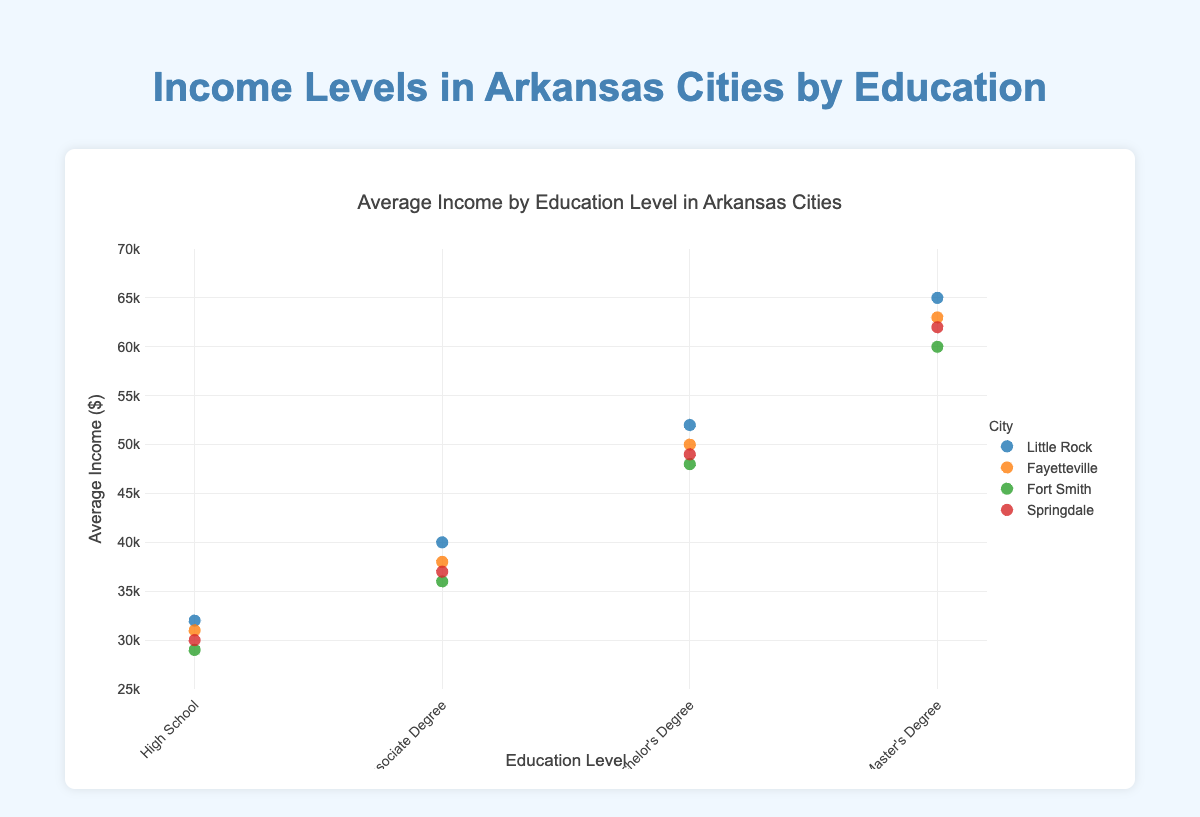what is the title of the chart? The title of the chart is found at the top center of the plot and helps identify the main topic or purpose of the visualization. In this case, it reads "Average Income by Education Level in Arkansas Cities."
Answer: Average Income by Education Level in Arkansas Cities What is the average income for individuals with a Master’s Degree in Springdale? To find the average income for individuals with a Master's Degree in Springdale, locate the point on the scatter plot for Springdale under the Master's Degree education level. The corresponding y-value (vertical axis) represents the average income. The figure shows this value is 62000.
Answer: 62000 Which city has the highest average income for people with a Bachelor’s Degree? To determine which city has the highest average income for people with a Bachelor's Degree, look at the scatter points for each city under the Bachelor's Degree category on the x-axis. Identify the point with the highest y-value (vertical axis). Little Rock has the highest y-value for a Bachelor's Degree, which is 52000.
Answer: Little Rock How does the average income for high school graduates in Fort Smith compare to those in Little Rock? To compare the average income for high school graduates in Fort Smith to those in Little Rock, find the points corresponding to "High School" under both cities on the scatter plot. Fort Smith's average income is 29000, and Little Rock's is 32000. Since 29000 is less than 32000, Fort Smith's high school graduates earn less on average compared to Little Rock's.
Answer: Fort Smith's average income is lower What is the range of average incomes for individuals with an Associate Degree across all cities? To find the range of average incomes for individuals with an Associate Degree, identify the y-values for all Associate Degree points across all cities. The values are 40000 (Little Rock), 38000 (Fayetteville), 36000 (Fort Smith), and 37000 (Springdale). The range is the difference between the highest and lowest values: 40000 - 36000 = 4000.
Answer: 4000 Which city shows the greatest increase in average income from High School to Master’s Degree? To determine which city shows the greatest increase in average income from High School to Master's Degree, calculate the difference between these two education levels for each city: Little Rock (65000 - 32000 = 33000), Fayetteville (63000 - 31000 = 32000), Fort Smith (60000 - 29000 = 31000), Springdale (62000 - 30000 = 32000). The city with the highest difference is Little Rock with an increase of 33000.
Answer: Little Rock What is the average income for individuals with Bachelor's Degree across all cities? Calculate the average income for individuals with a Bachelor's Degree by adding the corresponding y-values and dividing by the number of cities. The y-values are 52000 (Little Rock), 50000 (Fayetteville), 48000 (Fort Smith), and 49000 (Springdale). The sum is 52000 + 50000 + 48000 + 49000 = 199000. The average is 199000/4 = 49750.
Answer: 49750 Which city has the smallest overall spread in average income across the four education levels? To find the city with the smallest overall spread in average income, calculate the spread (the difference between the highest and lowest average incomes) for each city: 
Little Rock (65000 - 32000 = 33000),
Fayetteville (63000 - 31000 = 32000),
Fort Smith (60000 - 29000 = 31000),
Springdale (62000 - 30000 = 32000). 
Fort Smith has the smallest spread of 31000.
Answer: Fort Smith 